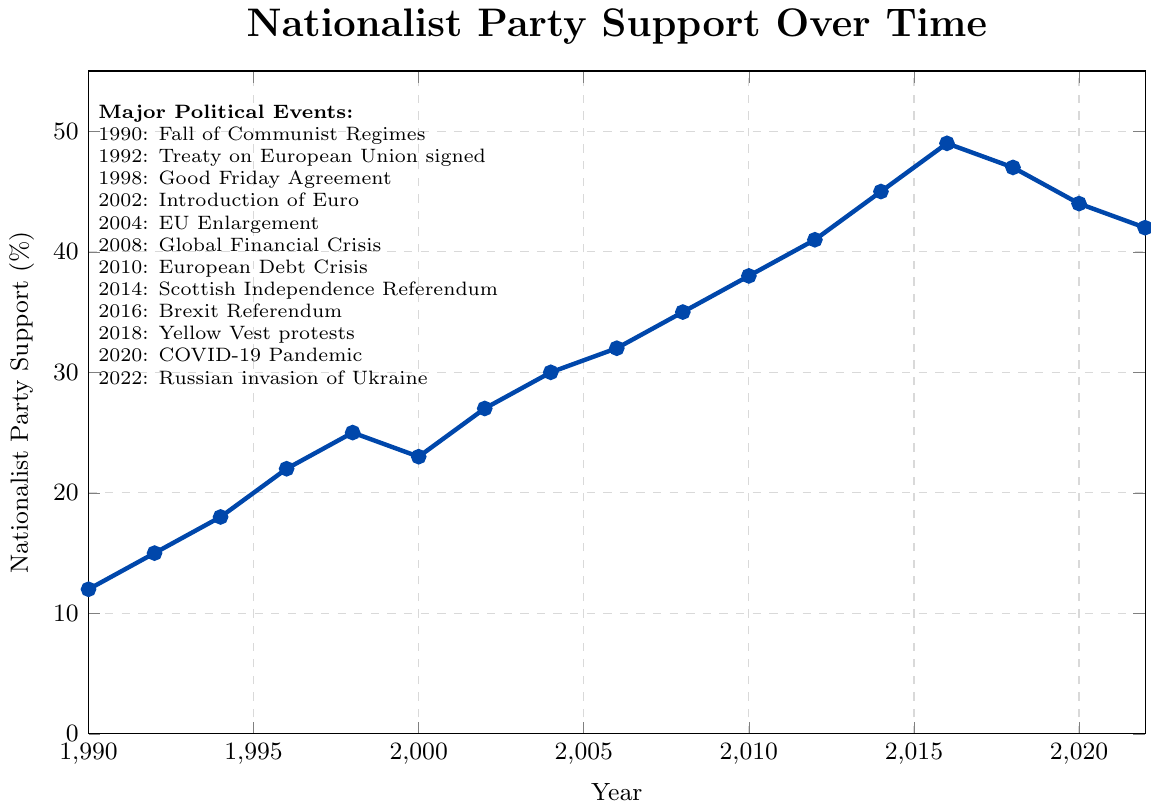What year did Nationalist Party support reach its highest point? Identify the highest value of support on the y-axis and note its corresponding year on the x-axis. The highest value is 49% in 2016.
Answer: 2016 What is the difference in Nationalist Party support between 2008 and 2010? Find the support level in 2008 (35%) and in 2010 (38%). Subtract the value in 2008 from the value in 2010 to get the difference: 38% - 35% = 3%.
Answer: 3% How did Nationalist Party support change after the Global Financial Crisis in 2008? Observe the support level in 2008 (35%) and note the values in subsequent years. Support increased to 38% in 2010, 41% in 2012, and 45% in 2014. This shows a steady rise following the crisis.
Answer: It increased Which event coincides with the peak in Nationalist Party support? Identify the peak support in 2016 and look for the event listed for 2016. The corresponding event is the Brexit Referendum.
Answer: Brexit Referendum During which event did Nationalist Party support first reach above 40%? Check the support levels and events around the point where support crosses 40%. Support first exceeds 40% with 45% in 2014; the event of that year is the Scottish Independence Referendum.
Answer: Scottish Independence Referendum What was the trend in Nationalist Party support from 2016 to 2022? Look at the support levels in 2016 (49%), 2018 (47%), 2020 (44%), and 2022 (42%). The trend shows a gradual decline from 49% in 2016 down to 42% in 2022.
Answer: Decreasing Compare the Nationalist Party support in 2004 to 2014. Which year had higher support and by how much? 2004 support was 30%, and 2014 support was 45%. 2014 had higher support by subtracting 30% from 45%, which is 15%.
Answer: 2014 by 15% What is the average Nationalist Party support from 1996 to 2002? Average support from 1996 (22%), 1998 (25%), 2000 (23%), and 2002 (27%) is calculated by summing these values (22 + 25 + 23 + 27 = 97) and dividing by the number of years (4). The average is 97 / 4 = 24.25%.
Answer: 24.25% What are the colors and markers used in the plot? Identify the visual attributes of the plot line and markers. The plot uses a blue line and circular markers (dots) at each data point.
Answer: Blue line with circular markers Did Nationalist Party support ever decline between two consecutive years? Provide an example if it did. Inspect the support values year by year. The support declined from 25% in 1998 to 23% in 2000 and from 49% in 2016 to 47% in 2018.
Answer: Yes, 1998 to 2000 and 2016 to 2018 